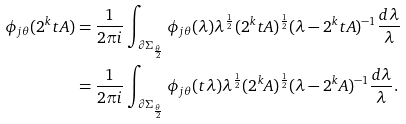<formula> <loc_0><loc_0><loc_500><loc_500>\phi _ { j \theta } ( 2 ^ { k } t A ) & = \frac { 1 } { 2 \pi i } \int _ { \partial \Sigma _ { \frac { \theta } { 2 } } } \phi _ { j \theta } ( \lambda ) \lambda ^ { \frac { 1 } { 2 } } ( 2 ^ { k } t A ) ^ { \frac { 1 } { 2 } } ( \lambda - 2 ^ { k } t A ) ^ { - 1 } \frac { d \lambda } { \lambda } \\ & = \frac { 1 } { 2 \pi i } \int _ { \partial \Sigma _ { \frac { \theta } { 2 } } } \phi _ { j \theta } ( t \lambda ) \lambda ^ { \frac { 1 } { 2 } } ( 2 ^ { k } A ) ^ { \frac { 1 } { 2 } } ( \lambda - 2 ^ { k } A ) ^ { - 1 } \frac { d \lambda } { \lambda } .</formula> 